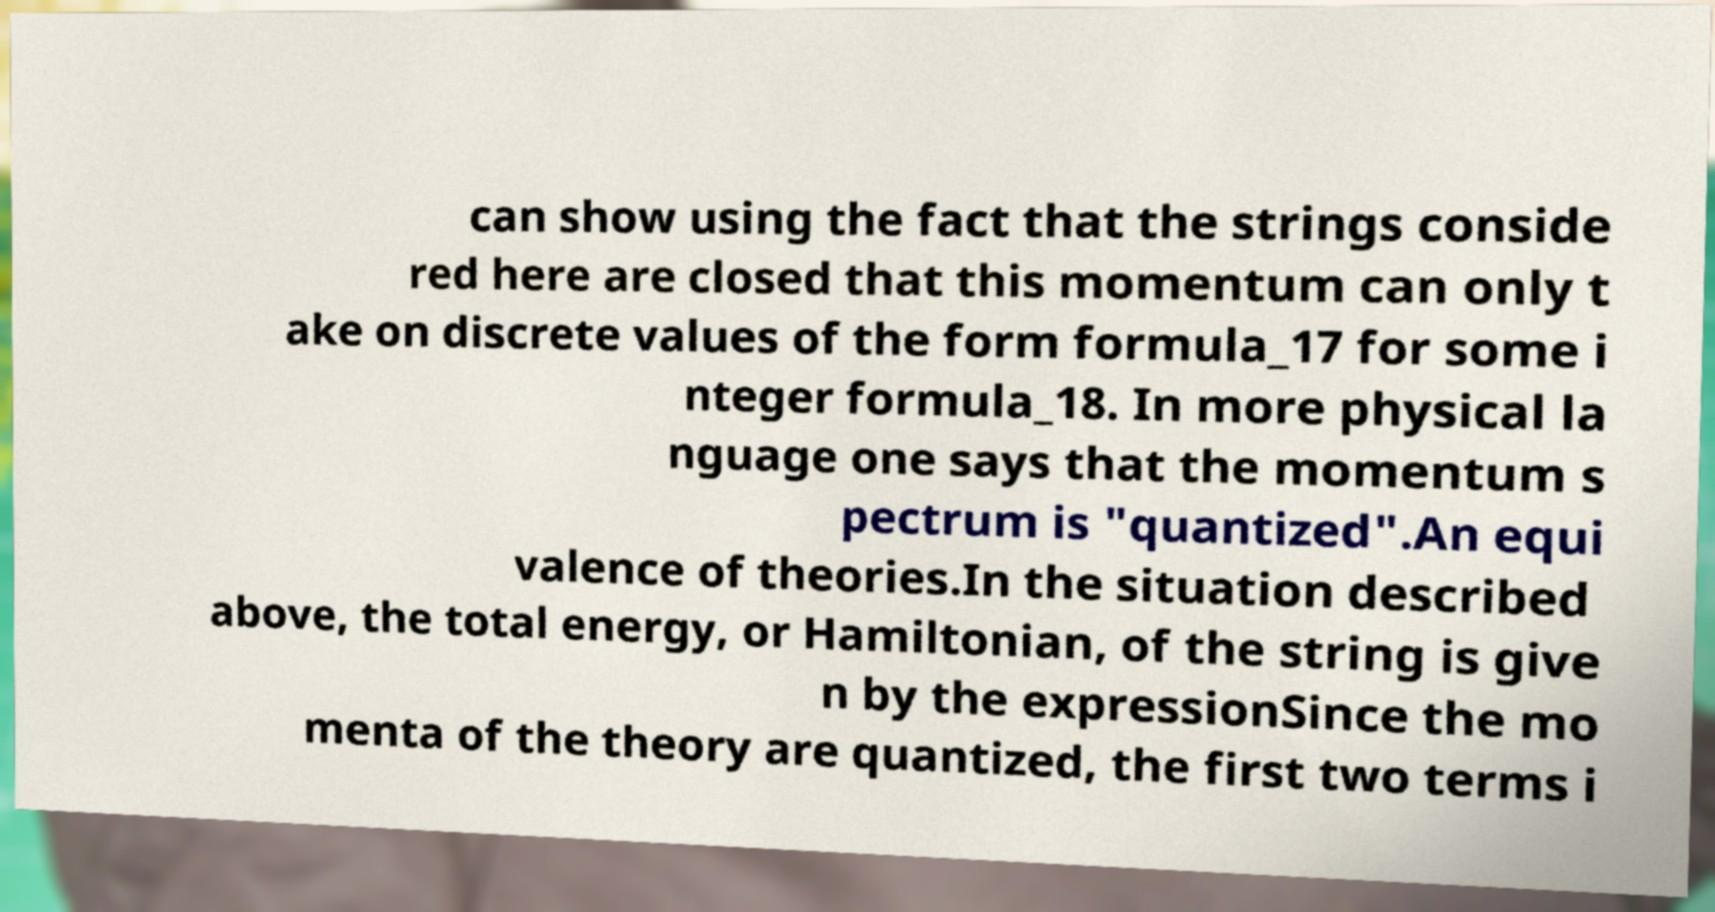There's text embedded in this image that I need extracted. Can you transcribe it verbatim? can show using the fact that the strings conside red here are closed that this momentum can only t ake on discrete values of the form formula_17 for some i nteger formula_18. In more physical la nguage one says that the momentum s pectrum is "quantized".An equi valence of theories.In the situation described above, the total energy, or Hamiltonian, of the string is give n by the expressionSince the mo menta of the theory are quantized, the first two terms i 